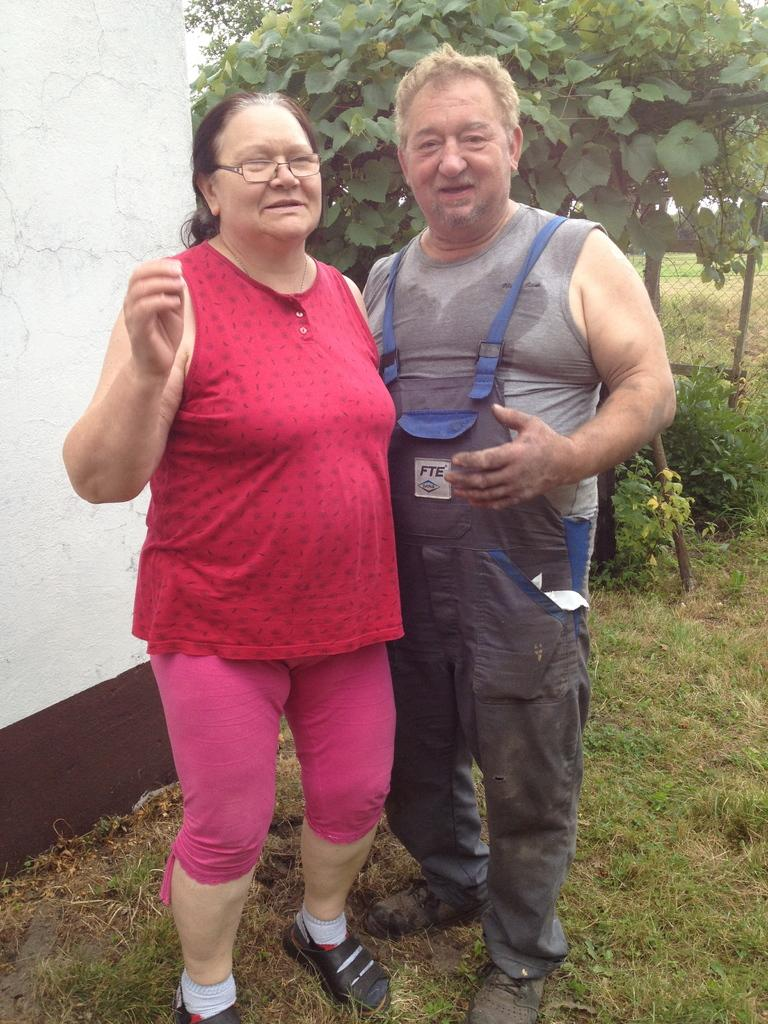How many people are present in the image? There are two people, a man and a woman, present in the image. What is the ground surface like in the image? There is grass visible in the image. What structures can be seen in the image? There is a wall and a fence in the image. What type of vegetation is present in the image? There is a group of plants in the image. What type of curtain can be seen hanging from the wall in the image? There is no curtain present in the image; only a wall and a fence are visible. 